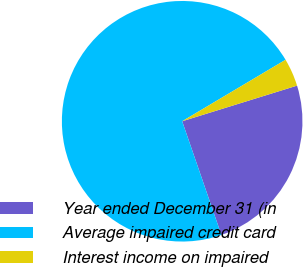<chart> <loc_0><loc_0><loc_500><loc_500><pie_chart><fcel>Year ended December 31 (in<fcel>Average impaired credit card<fcel>Interest income on impaired<nl><fcel>24.5%<fcel>71.75%<fcel>3.75%<nl></chart> 